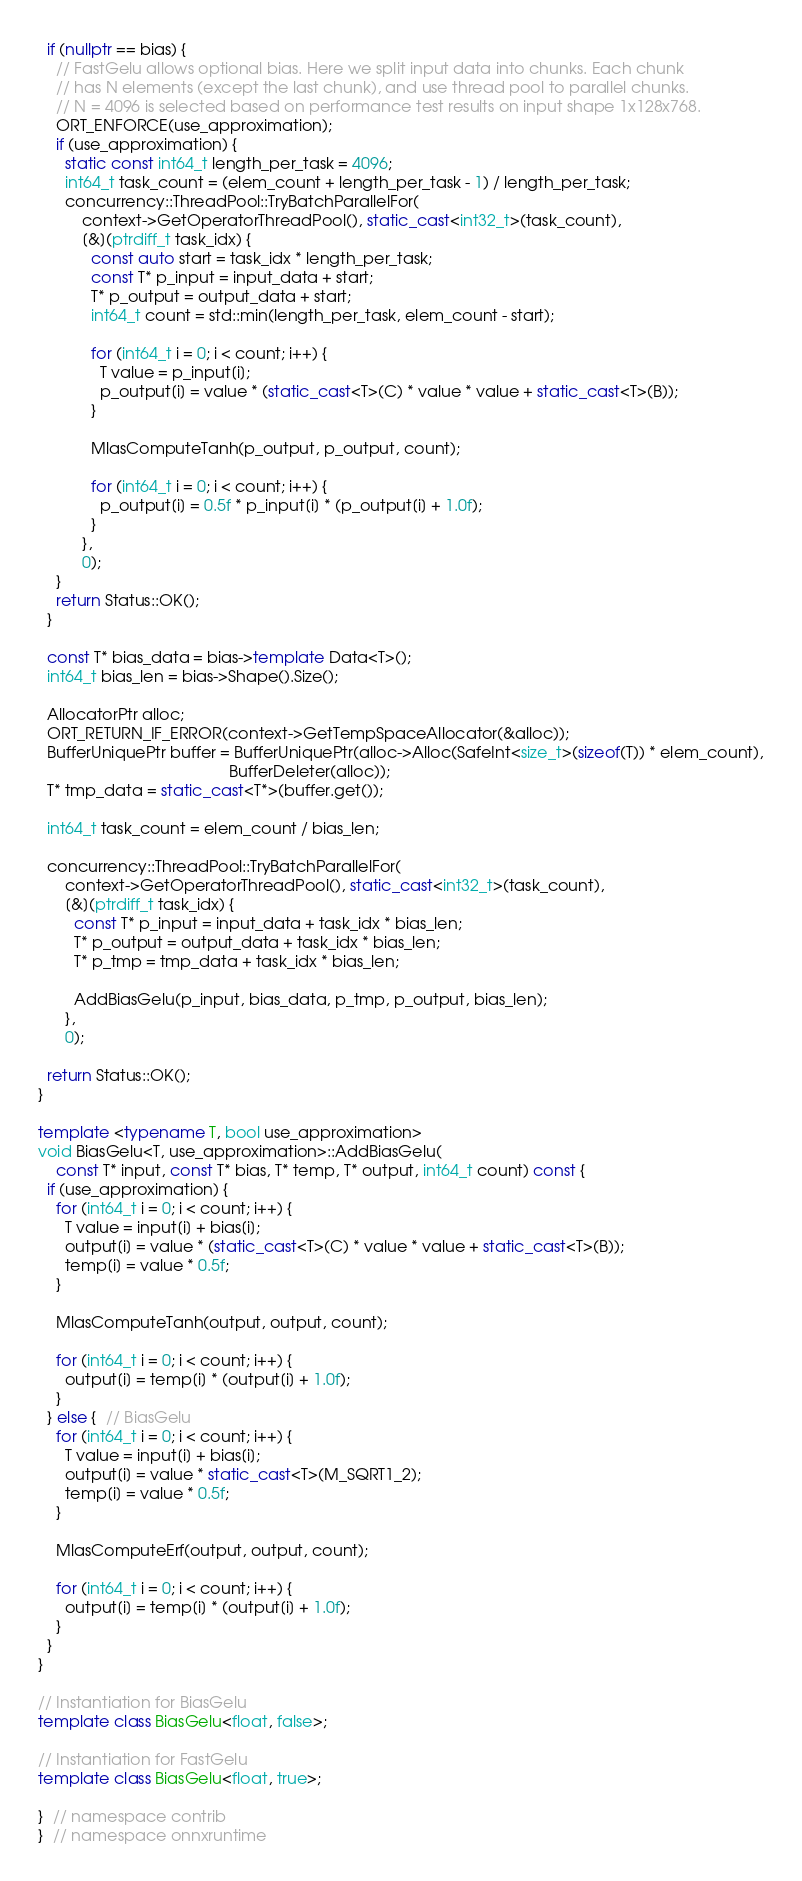<code> <loc_0><loc_0><loc_500><loc_500><_C++_>  if (nullptr == bias) {
    // FastGelu allows optional bias. Here we split input data into chunks. Each chunk
    // has N elements (except the last chunk), and use thread pool to parallel chunks.
    // N = 4096 is selected based on performance test results on input shape 1x128x768.
    ORT_ENFORCE(use_approximation);
    if (use_approximation) {
      static const int64_t length_per_task = 4096;
      int64_t task_count = (elem_count + length_per_task - 1) / length_per_task;
      concurrency::ThreadPool::TryBatchParallelFor(
          context->GetOperatorThreadPool(), static_cast<int32_t>(task_count),
          [&](ptrdiff_t task_idx) {
            const auto start = task_idx * length_per_task;
            const T* p_input = input_data + start;
            T* p_output = output_data + start;
            int64_t count = std::min(length_per_task, elem_count - start);

            for (int64_t i = 0; i < count; i++) {
              T value = p_input[i];
              p_output[i] = value * (static_cast<T>(C) * value * value + static_cast<T>(B));
            }

            MlasComputeTanh(p_output, p_output, count);

            for (int64_t i = 0; i < count; i++) {
              p_output[i] = 0.5f * p_input[i] * (p_output[i] + 1.0f);
            }
          },
          0);
    }
    return Status::OK();
  }

  const T* bias_data = bias->template Data<T>();
  int64_t bias_len = bias->Shape().Size();

  AllocatorPtr alloc;
  ORT_RETURN_IF_ERROR(context->GetTempSpaceAllocator(&alloc));
  BufferUniquePtr buffer = BufferUniquePtr(alloc->Alloc(SafeInt<size_t>(sizeof(T)) * elem_count),
                                           BufferDeleter(alloc));
  T* tmp_data = static_cast<T*>(buffer.get());

  int64_t task_count = elem_count / bias_len;

  concurrency::ThreadPool::TryBatchParallelFor(
      context->GetOperatorThreadPool(), static_cast<int32_t>(task_count),
      [&](ptrdiff_t task_idx) {
        const T* p_input = input_data + task_idx * bias_len;
        T* p_output = output_data + task_idx * bias_len;
        T* p_tmp = tmp_data + task_idx * bias_len;

        AddBiasGelu(p_input, bias_data, p_tmp, p_output, bias_len);
      },
      0);

  return Status::OK();
}

template <typename T, bool use_approximation>
void BiasGelu<T, use_approximation>::AddBiasGelu(
    const T* input, const T* bias, T* temp, T* output, int64_t count) const {
  if (use_approximation) {
    for (int64_t i = 0; i < count; i++) {
      T value = input[i] + bias[i];
      output[i] = value * (static_cast<T>(C) * value * value + static_cast<T>(B));
      temp[i] = value * 0.5f;
    }

    MlasComputeTanh(output, output, count);

    for (int64_t i = 0; i < count; i++) {
      output[i] = temp[i] * (output[i] + 1.0f);
    }
  } else {  // BiasGelu
    for (int64_t i = 0; i < count; i++) {
      T value = input[i] + bias[i];
      output[i] = value * static_cast<T>(M_SQRT1_2);
      temp[i] = value * 0.5f;
    }

    MlasComputeErf(output, output, count);

    for (int64_t i = 0; i < count; i++) {
      output[i] = temp[i] * (output[i] + 1.0f);
    }
  }
}

// Instantiation for BiasGelu
template class BiasGelu<float, false>;

// Instantiation for FastGelu
template class BiasGelu<float, true>;

}  // namespace contrib
}  // namespace onnxruntime
</code> 